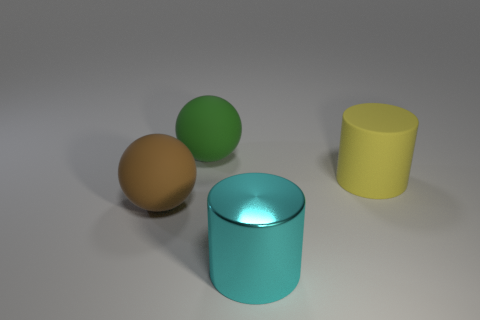How many objects are balls or large brown balls behind the big cyan metallic object?
Keep it short and to the point. 2. What color is the matte object on the right side of the big matte sphere behind the yellow matte thing?
Keep it short and to the point. Yellow. There is a large thing that is behind the large rubber cylinder; what material is it?
Your response must be concise. Rubber. Does the object that is behind the large yellow cylinder have the same material as the yellow object?
Provide a succinct answer. Yes. What number of matte cylinders are there?
Provide a short and direct response. 1. What number of things are big green things or cylinders?
Offer a terse response. 3. How many metal cylinders are behind the rubber object that is to the right of the rubber ball that is behind the yellow object?
Your response must be concise. 0. Is there any other thing that has the same color as the metallic cylinder?
Offer a terse response. No. Is the number of objects left of the metallic cylinder greater than the number of big objects on the right side of the brown thing?
Provide a short and direct response. No. What is the material of the big cyan thing?
Your answer should be compact. Metal. 